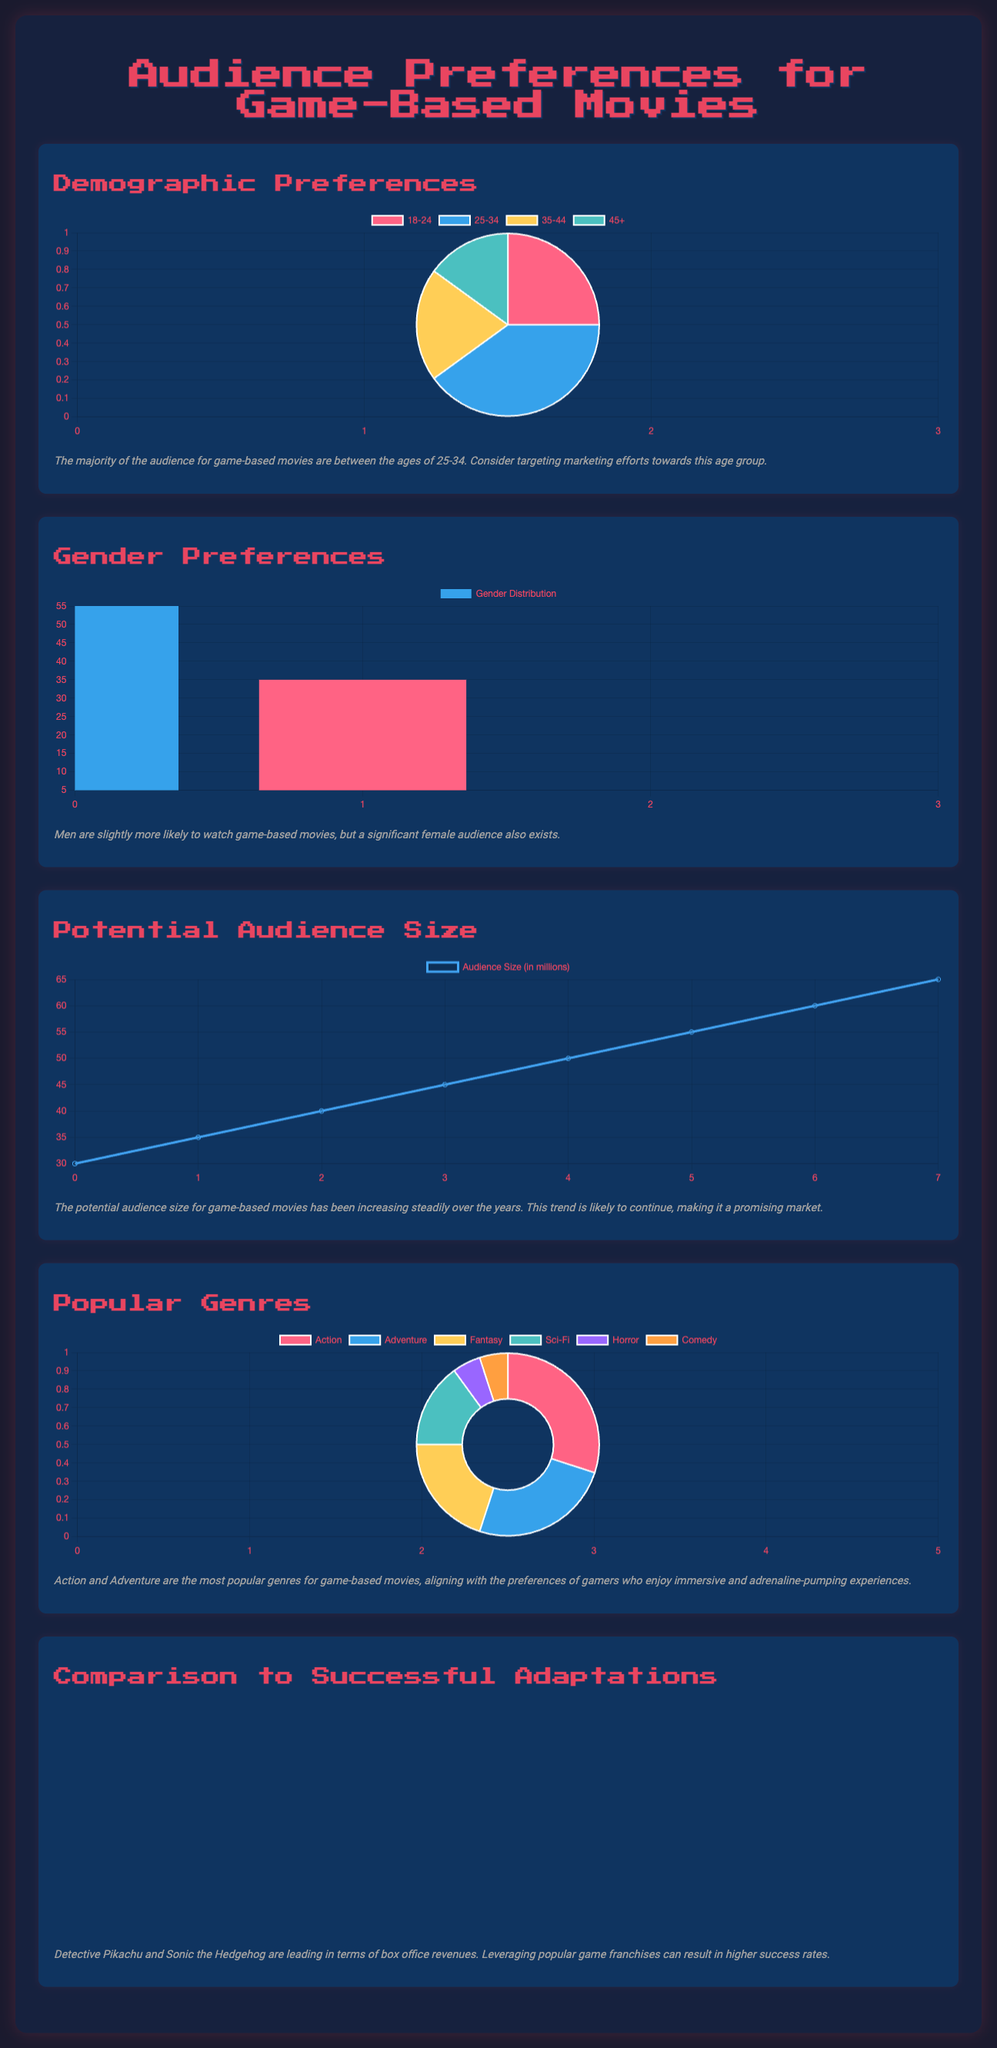What age group has the highest audience preference? The age group with the highest audience preference is represented in the demographic chart, indicating that 25-34 years is the largest segment.
Answer: 25-34 What percentage of the audience is female? The gender distribution shows that 35% of the audience identifies as female.
Answer: 35% What year did the audience size reach 60 million? The audience size chart shows that 60 million was reached in the year 2021.
Answer: 2021 Which genre has the highest popularity? The popular genres chart indicates that the Action genre has the highest popularity at 30%.
Answer: Action What is the box office revenue for Detective Pikachu? According to the adaptations chart, Detective Pikachu had a box office revenue of 433 million dollars.
Answer: 433 Is the potential audience size increasing or decreasing? The audience size data shows a steady increase in potential audience size over the years.
Answer: Increasing How many genres are represented in the popular genres chart? The popular genres chart features six different genres.
Answer: Six What color represents Non-Binary in the gender chart? In the gender distribution chart, Non-Binary is represented by the color yellow.
Answer: Yellow Which game adaptation has the lowest box office revenue? The adaptations chart shows that Mortal Kombat has the lowest box office revenue at 83 million dollars.
Answer: 83 